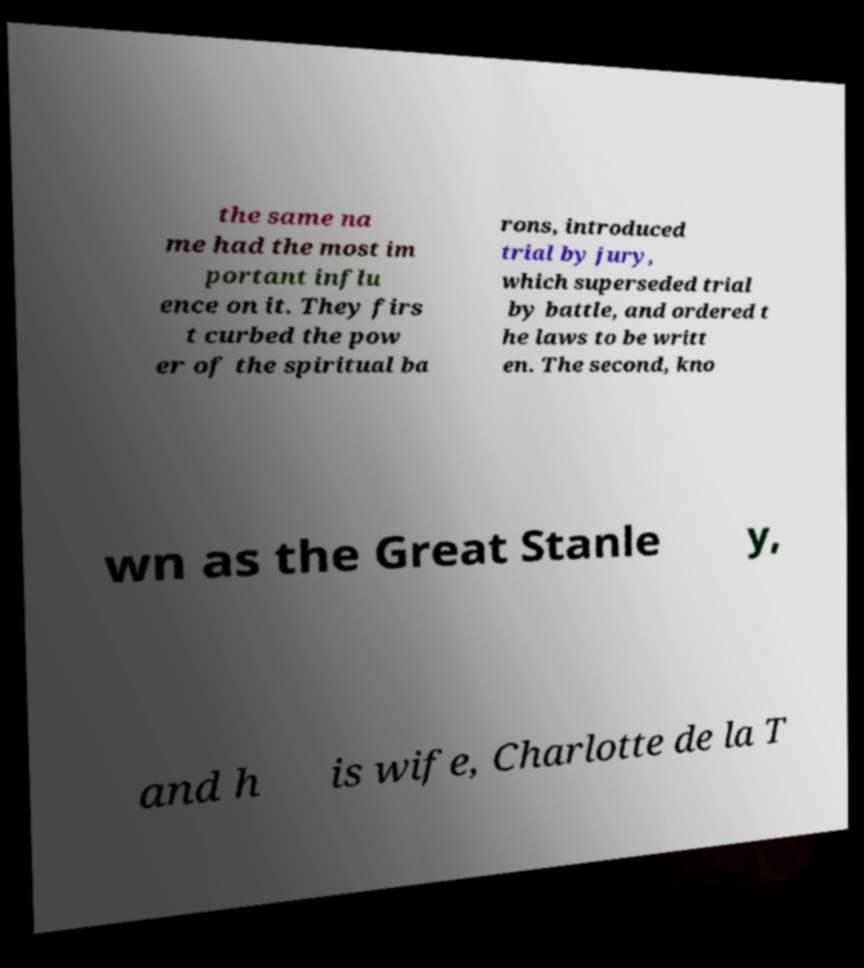Could you extract and type out the text from this image? the same na me had the most im portant influ ence on it. They firs t curbed the pow er of the spiritual ba rons, introduced trial by jury, which superseded trial by battle, and ordered t he laws to be writt en. The second, kno wn as the Great Stanle y, and h is wife, Charlotte de la T 